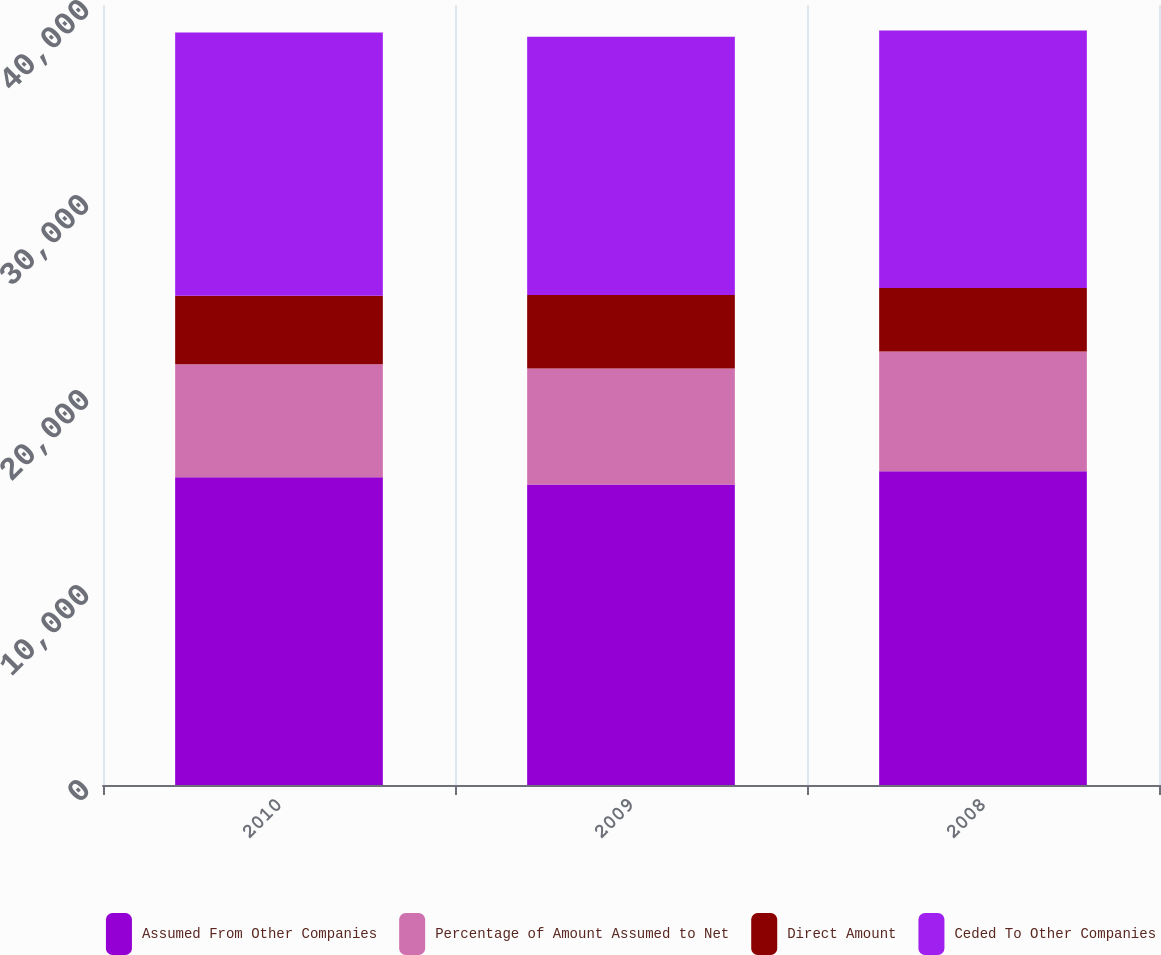Convert chart to OTSL. <chart><loc_0><loc_0><loc_500><loc_500><stacked_bar_chart><ecel><fcel>2010<fcel>2009<fcel>2008<nl><fcel>Assumed From Other Companies<fcel>15780<fcel>15415<fcel>16087<nl><fcel>Percentage of Amount Assumed to Net<fcel>5792<fcel>5943<fcel>6144<nl><fcel>Direct Amount<fcel>3516<fcel>3768<fcel>3260<nl><fcel>Ceded To Other Companies<fcel>13504<fcel>13240<fcel>13203<nl></chart> 